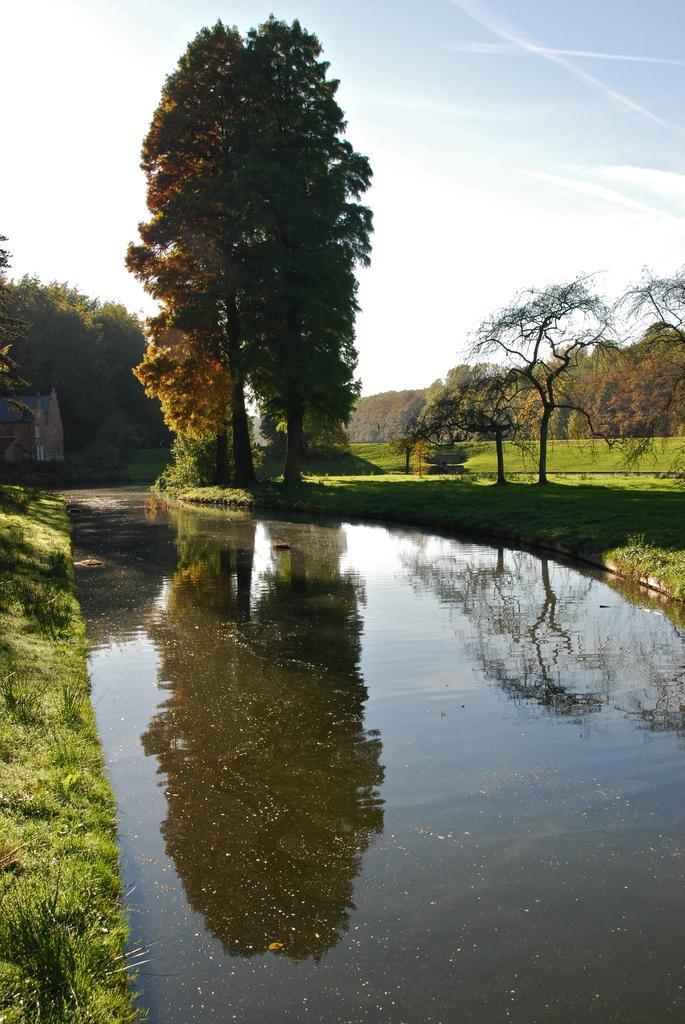Could you give a brief overview of what you see in this image? In this picture we can see grass, water, trees and house. In the background of the image we can see the sky. 